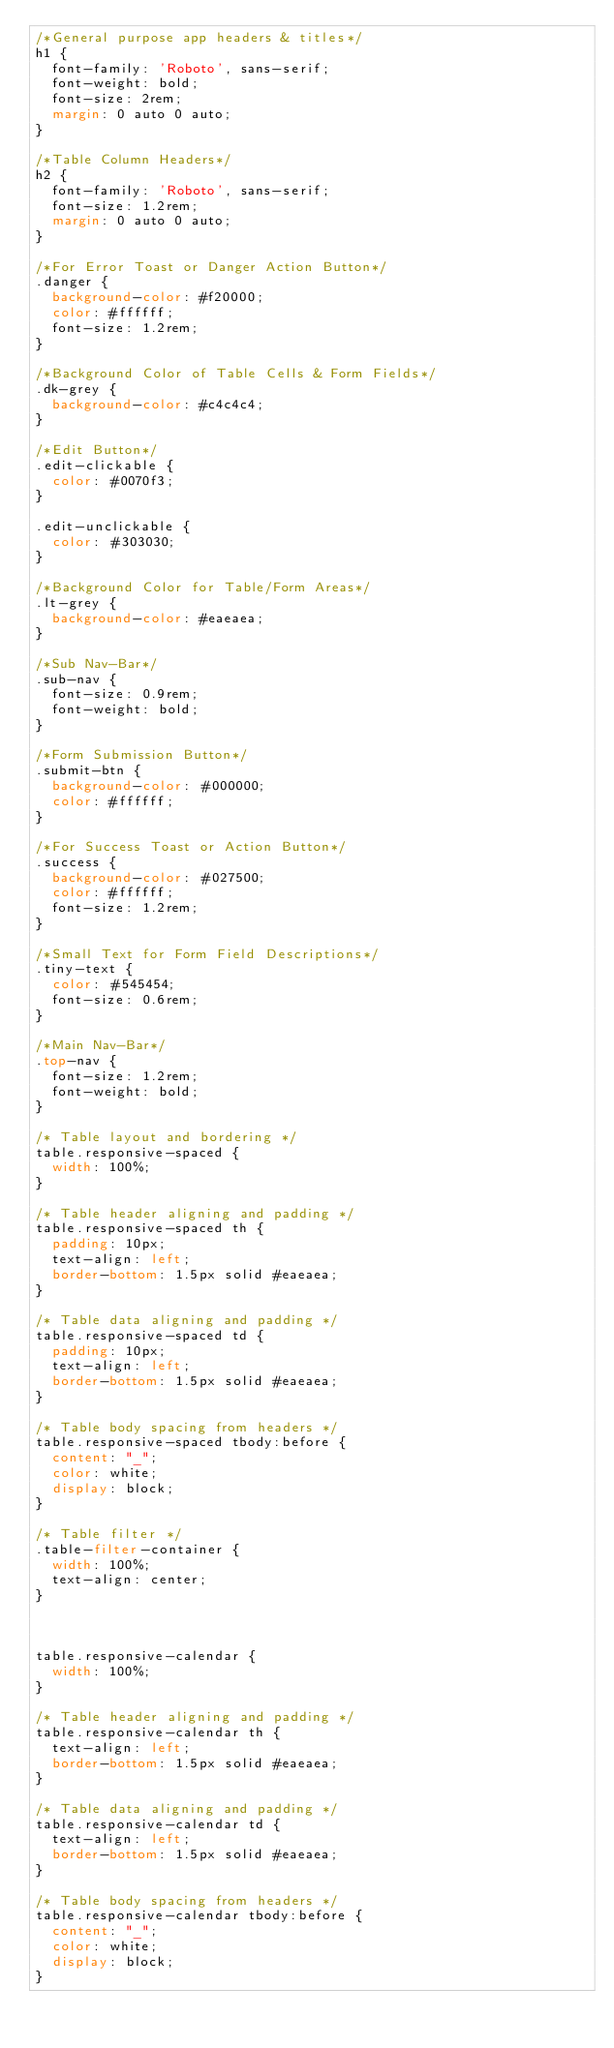Convert code to text. <code><loc_0><loc_0><loc_500><loc_500><_CSS_>/*General purpose app headers & titles*/
h1 {
  font-family: 'Roboto', sans-serif;
  font-weight: bold;
  font-size: 2rem;
  margin: 0 auto 0 auto;
}

/*Table Column Headers*/
h2 {
  font-family: 'Roboto', sans-serif;
  font-size: 1.2rem;
  margin: 0 auto 0 auto;
}

/*For Error Toast or Danger Action Button*/
.danger {
  background-color: #f20000;
  color: #ffffff;
  font-size: 1.2rem;
}

/*Background Color of Table Cells & Form Fields*/
.dk-grey {
  background-color: #c4c4c4;
}

/*Edit Button*/
.edit-clickable {
  color: #0070f3;
}

.edit-unclickable {
  color: #303030;
}

/*Background Color for Table/Form Areas*/
.lt-grey {
  background-color: #eaeaea;
}

/*Sub Nav-Bar*/
.sub-nav {
  font-size: 0.9rem;
  font-weight: bold;
}

/*Form Submission Button*/
.submit-btn {
  background-color: #000000;
  color: #ffffff;
}

/*For Success Toast or Action Button*/
.success {
  background-color: #027500;
  color: #ffffff;
  font-size: 1.2rem;
}

/*Small Text for Form Field Descriptions*/
.tiny-text {
  color: #545454;
  font-size: 0.6rem;
}

/*Main Nav-Bar*/
.top-nav {
  font-size: 1.2rem;
  font-weight: bold;
}

/* Table layout and bordering */
table.responsive-spaced {
  width: 100%;
}

/* Table header aligning and padding */
table.responsive-spaced th {
  padding: 10px;
  text-align: left;
  border-bottom: 1.5px solid #eaeaea;
}

/* Table data aligning and padding */
table.responsive-spaced td {
  padding: 10px;
  text-align: left;
  border-bottom: 1.5px solid #eaeaea;
}

/* Table body spacing from headers */
table.responsive-spaced tbody:before {
  content: "_";
  color: white;
  display: block;
}

/* Table filter */
.table-filter-container {
  width: 100%;
  text-align: center;
}



table.responsive-calendar {
  width: 100%;
}

/* Table header aligning and padding */
table.responsive-calendar th {
  text-align: left;
  border-bottom: 1.5px solid #eaeaea;
}

/* Table data aligning and padding */
table.responsive-calendar td {
  text-align: left;
  border-bottom: 1.5px solid #eaeaea;
}

/* Table body spacing from headers */
table.responsive-calendar tbody:before {
  content: "_";
  color: white;
  display: block;
}

</code> 